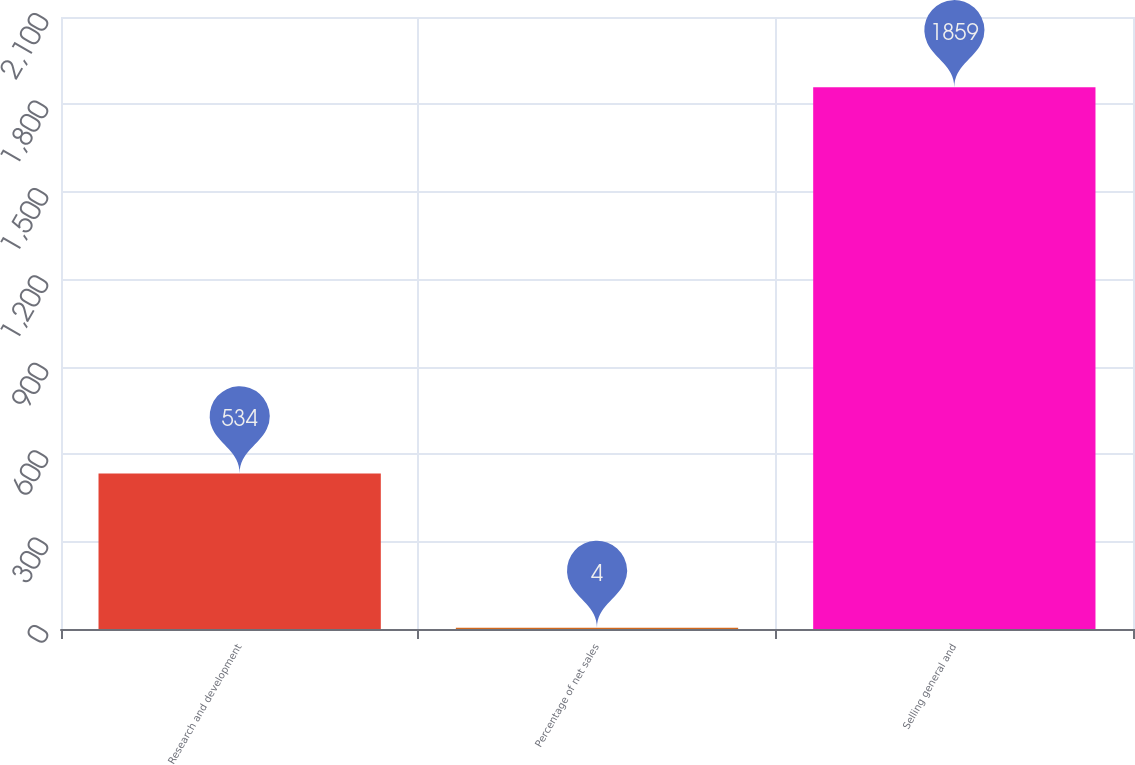Convert chart to OTSL. <chart><loc_0><loc_0><loc_500><loc_500><bar_chart><fcel>Research and development<fcel>Percentage of net sales<fcel>Selling general and<nl><fcel>534<fcel>4<fcel>1859<nl></chart> 